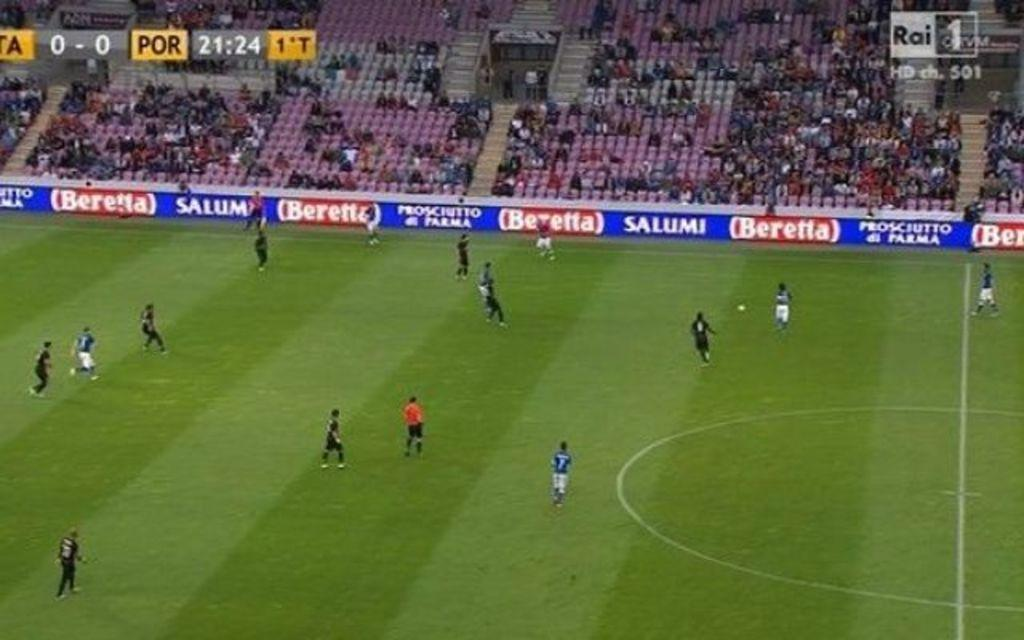<image>
Relay a brief, clear account of the picture shown. Salumi signs line the edge of a large soccer stadium. 